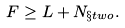Convert formula to latex. <formula><loc_0><loc_0><loc_500><loc_500>F \geq L + N _ { \S t w o } .</formula> 